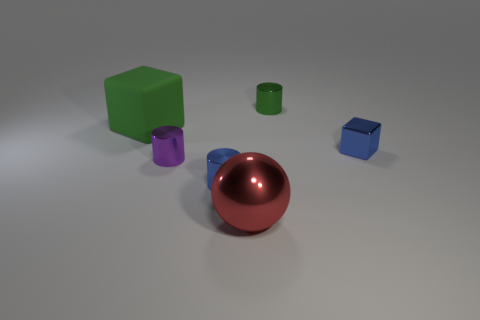How big is the rubber thing?
Your answer should be compact. Large. Is the shape of the small blue object that is left of the large red object the same as the big thing that is behind the tiny blue cube?
Ensure brevity in your answer.  No. The green metal thing that is the same size as the purple object is what shape?
Offer a very short reply. Cylinder. The block that is made of the same material as the green cylinder is what color?
Offer a terse response. Blue. There is a big red shiny thing; is it the same shape as the tiny metal thing that is behind the big green rubber object?
Provide a short and direct response. No. What material is the object that is the same color as the big rubber block?
Offer a terse response. Metal. There is a green object that is the same size as the purple metal object; what is it made of?
Offer a terse response. Metal. Are there any small metallic cylinders that have the same color as the small metallic cube?
Ensure brevity in your answer.  Yes. There is a metallic object that is behind the big metallic ball and in front of the small purple metal thing; what is its shape?
Your response must be concise. Cylinder. What number of red things are made of the same material as the tiny cube?
Provide a short and direct response. 1. 